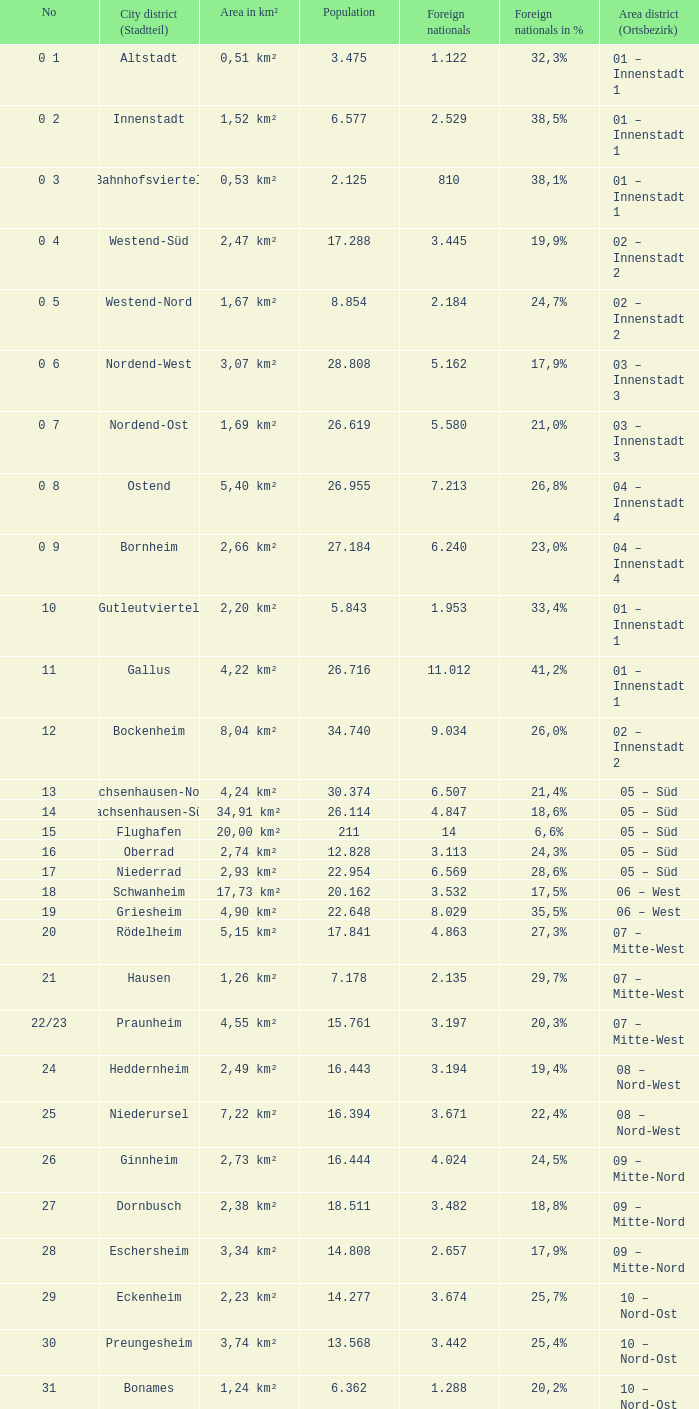What is the number of the city district of stadtteil where foreigners are 5.162? 1.0. Could you help me parse every detail presented in this table? {'header': ['No', 'City district (Stadtteil)', 'Area in km²', 'Population', 'Foreign nationals', 'Foreign nationals in %', 'Area district (Ortsbezirk)'], 'rows': [['0 1', 'Altstadt', '0,51 km²', '3.475', '1.122', '32,3%', '01 – Innenstadt 1'], ['0 2', 'Innenstadt', '1,52 km²', '6.577', '2.529', '38,5%', '01 – Innenstadt 1'], ['0 3', 'Bahnhofsviertel', '0,53 km²', '2.125', '810', '38,1%', '01 – Innenstadt 1'], ['0 4', 'Westend-Süd', '2,47 km²', '17.288', '3.445', '19,9%', '02 – Innenstadt 2'], ['0 5', 'Westend-Nord', '1,67 km²', '8.854', '2.184', '24,7%', '02 – Innenstadt 2'], ['0 6', 'Nordend-West', '3,07 km²', '28.808', '5.162', '17,9%', '03 – Innenstadt 3'], ['0 7', 'Nordend-Ost', '1,69 km²', '26.619', '5.580', '21,0%', '03 – Innenstadt 3'], ['0 8', 'Ostend', '5,40 km²', '26.955', '7.213', '26,8%', '04 – Innenstadt 4'], ['0 9', 'Bornheim', '2,66 km²', '27.184', '6.240', '23,0%', '04 – Innenstadt 4'], ['10', 'Gutleutviertel', '2,20 km²', '5.843', '1.953', '33,4%', '01 – Innenstadt 1'], ['11', 'Gallus', '4,22 km²', '26.716', '11.012', '41,2%', '01 – Innenstadt 1'], ['12', 'Bockenheim', '8,04 km²', '34.740', '9.034', '26,0%', '02 – Innenstadt 2'], ['13', 'Sachsenhausen-Nord', '4,24 km²', '30.374', '6.507', '21,4%', '05 – Süd'], ['14', 'Sachsenhausen-Süd', '34,91 km²', '26.114', '4.847', '18,6%', '05 – Süd'], ['15', 'Flughafen', '20,00 km²', '211', '14', '6,6%', '05 – Süd'], ['16', 'Oberrad', '2,74 km²', '12.828', '3.113', '24,3%', '05 – Süd'], ['17', 'Niederrad', '2,93 km²', '22.954', '6.569', '28,6%', '05 – Süd'], ['18', 'Schwanheim', '17,73 km²', '20.162', '3.532', '17,5%', '06 – West'], ['19', 'Griesheim', '4,90 km²', '22.648', '8.029', '35,5%', '06 – West'], ['20', 'Rödelheim', '5,15 km²', '17.841', '4.863', '27,3%', '07 – Mitte-West'], ['21', 'Hausen', '1,26 km²', '7.178', '2.135', '29,7%', '07 – Mitte-West'], ['22/23', 'Praunheim', '4,55 km²', '15.761', '3.197', '20,3%', '07 – Mitte-West'], ['24', 'Heddernheim', '2,49 km²', '16.443', '3.194', '19,4%', '08 – Nord-West'], ['25', 'Niederursel', '7,22 km²', '16.394', '3.671', '22,4%', '08 – Nord-West'], ['26', 'Ginnheim', '2,73 km²', '16.444', '4.024', '24,5%', '09 – Mitte-Nord'], ['27', 'Dornbusch', '2,38 km²', '18.511', '3.482', '18,8%', '09 – Mitte-Nord'], ['28', 'Eschersheim', '3,34 km²', '14.808', '2.657', '17,9%', '09 – Mitte-Nord'], ['29', 'Eckenheim', '2,23 km²', '14.277', '3.674', '25,7%', '10 – Nord-Ost'], ['30', 'Preungesheim', '3,74 km²', '13.568', '3.442', '25,4%', '10 – Nord-Ost'], ['31', 'Bonames', '1,24 km²', '6.362', '1.288', '20,2%', '10 – Nord-Ost'], ['32', 'Berkersheim', '3,18 km²', '3.400', '592', '17,4%', '10 – Nord-Ost'], ['33', 'Riederwald', '1,04 km²', '4.911', '1.142', '23,3%', '11 – Ost'], ['34', 'Seckbach', '8,04 km²', '10.194', '1.969', '19,3%', '11 – Ost'], ['35', 'Fechenheim', '7,18 km²', '16.061', '5.635', '35,1%', '11 – Ost'], ['36', 'Höchst', '4,73 km²', '13.888', '5.279', '38,0%', '06 – West'], ['37', 'Nied', '3,82 km²', '17.829', '5.224', '29,3%', '06 – West'], ['38', 'Sindlingen', '3,98 km²', '9.032', '2.076', '23,0%', '06 – West'], ['39', 'Zeilsheim', '5,47 km²', '11.984', '2.555', '21,3%', '06 – West'], ['40', 'Unterliederbach', '5,85 km²', '14.350', '3.511', '24,5%', '06 – West'], ['41', 'Sossenheim', '5,97 km²', '15.853', '4.235', '26,7%', '06 – West'], ['42', 'Nieder-Erlenbach', '8,34 km²', '4.629', '496', '10,7%', '13 – Nieder-Erlenbach'], ['43', 'Kalbach-Riedberg', '6,90 km²', '8.482', '1.279', '15,1%', '12 – Kalbach-Riedberg'], ['44', 'Harheim', '5,02 km²', '4.294', '446', '10,4%', '14 – Harheim'], ['45', 'Nieder-Eschbach', '6,35 km²', '11.499', '1.978', '17,2%', '15 – Nieder-Eschbach'], ['46', 'Bergen-Enkheim', '12,54 km²', '17.954', '2.764', '15,4%', '16 – Bergen-Enkheim'], ['47', 'Frankfurter Berg', '2,16 km²', '7.149', '1.715', '24,0%', '10 – Nord-Ost']]} 